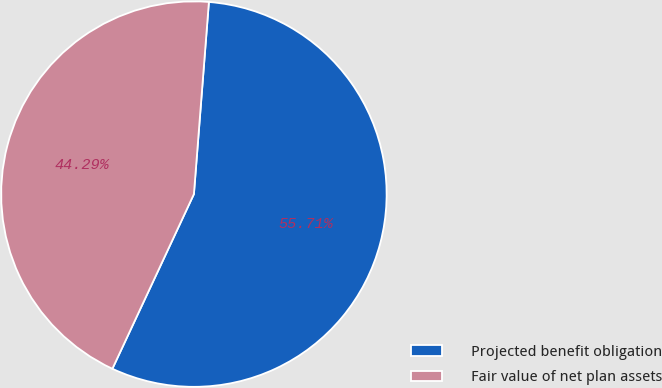Convert chart to OTSL. <chart><loc_0><loc_0><loc_500><loc_500><pie_chart><fcel>Projected benefit obligation<fcel>Fair value of net plan assets<nl><fcel>55.71%<fcel>44.29%<nl></chart> 